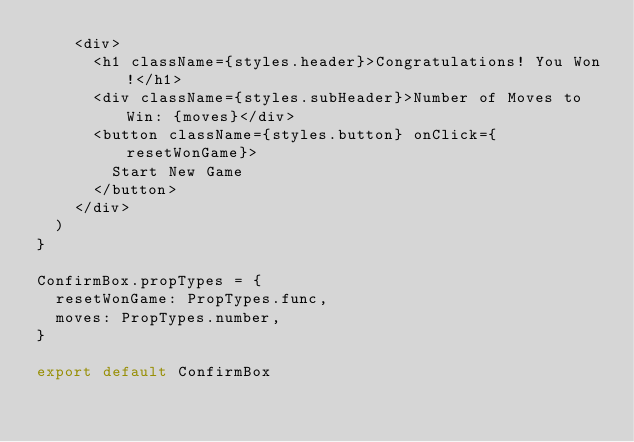Convert code to text. <code><loc_0><loc_0><loc_500><loc_500><_JavaScript_>    <div>
      <h1 className={styles.header}>Congratulations! You Won!</h1>
      <div className={styles.subHeader}>Number of Moves to Win: {moves}</div>
      <button className={styles.button} onClick={resetWonGame}>
        Start New Game
      </button>
    </div>
  )
}

ConfirmBox.propTypes = {
  resetWonGame: PropTypes.func,
  moves: PropTypes.number,
}

export default ConfirmBox
</code> 